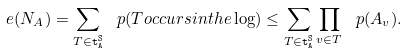Convert formula to latex. <formula><loc_0><loc_0><loc_500><loc_500>\ e ( N _ { A } ) = \sum _ { T \in \tt t ^ { S } _ { A } } \ p ( T o c c u r s i n t h e \log ) \leq \sum _ { T \in \tt t ^ { S } _ { A } } \prod _ { v \in T } \ p ( A _ { v } ) .</formula> 